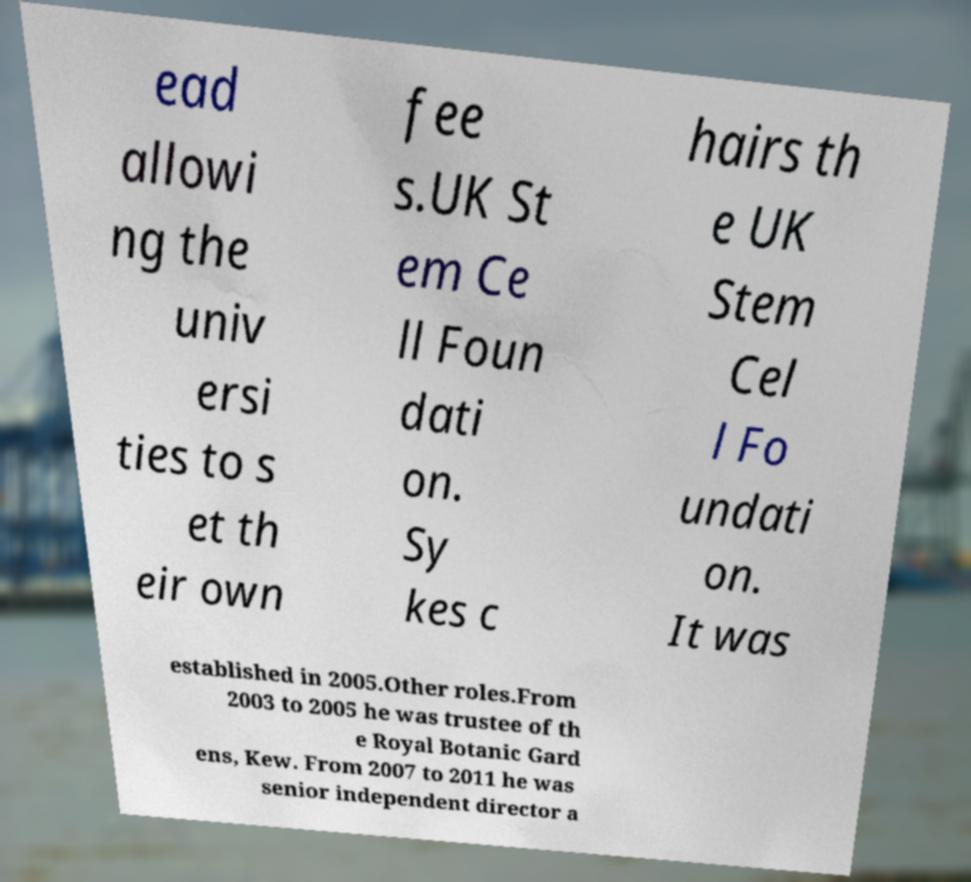Please read and relay the text visible in this image. What does it say? ead allowi ng the univ ersi ties to s et th eir own fee s.UK St em Ce ll Foun dati on. Sy kes c hairs th e UK Stem Cel l Fo undati on. It was established in 2005.Other roles.From 2003 to 2005 he was trustee of th e Royal Botanic Gard ens, Kew. From 2007 to 2011 he was senior independent director a 